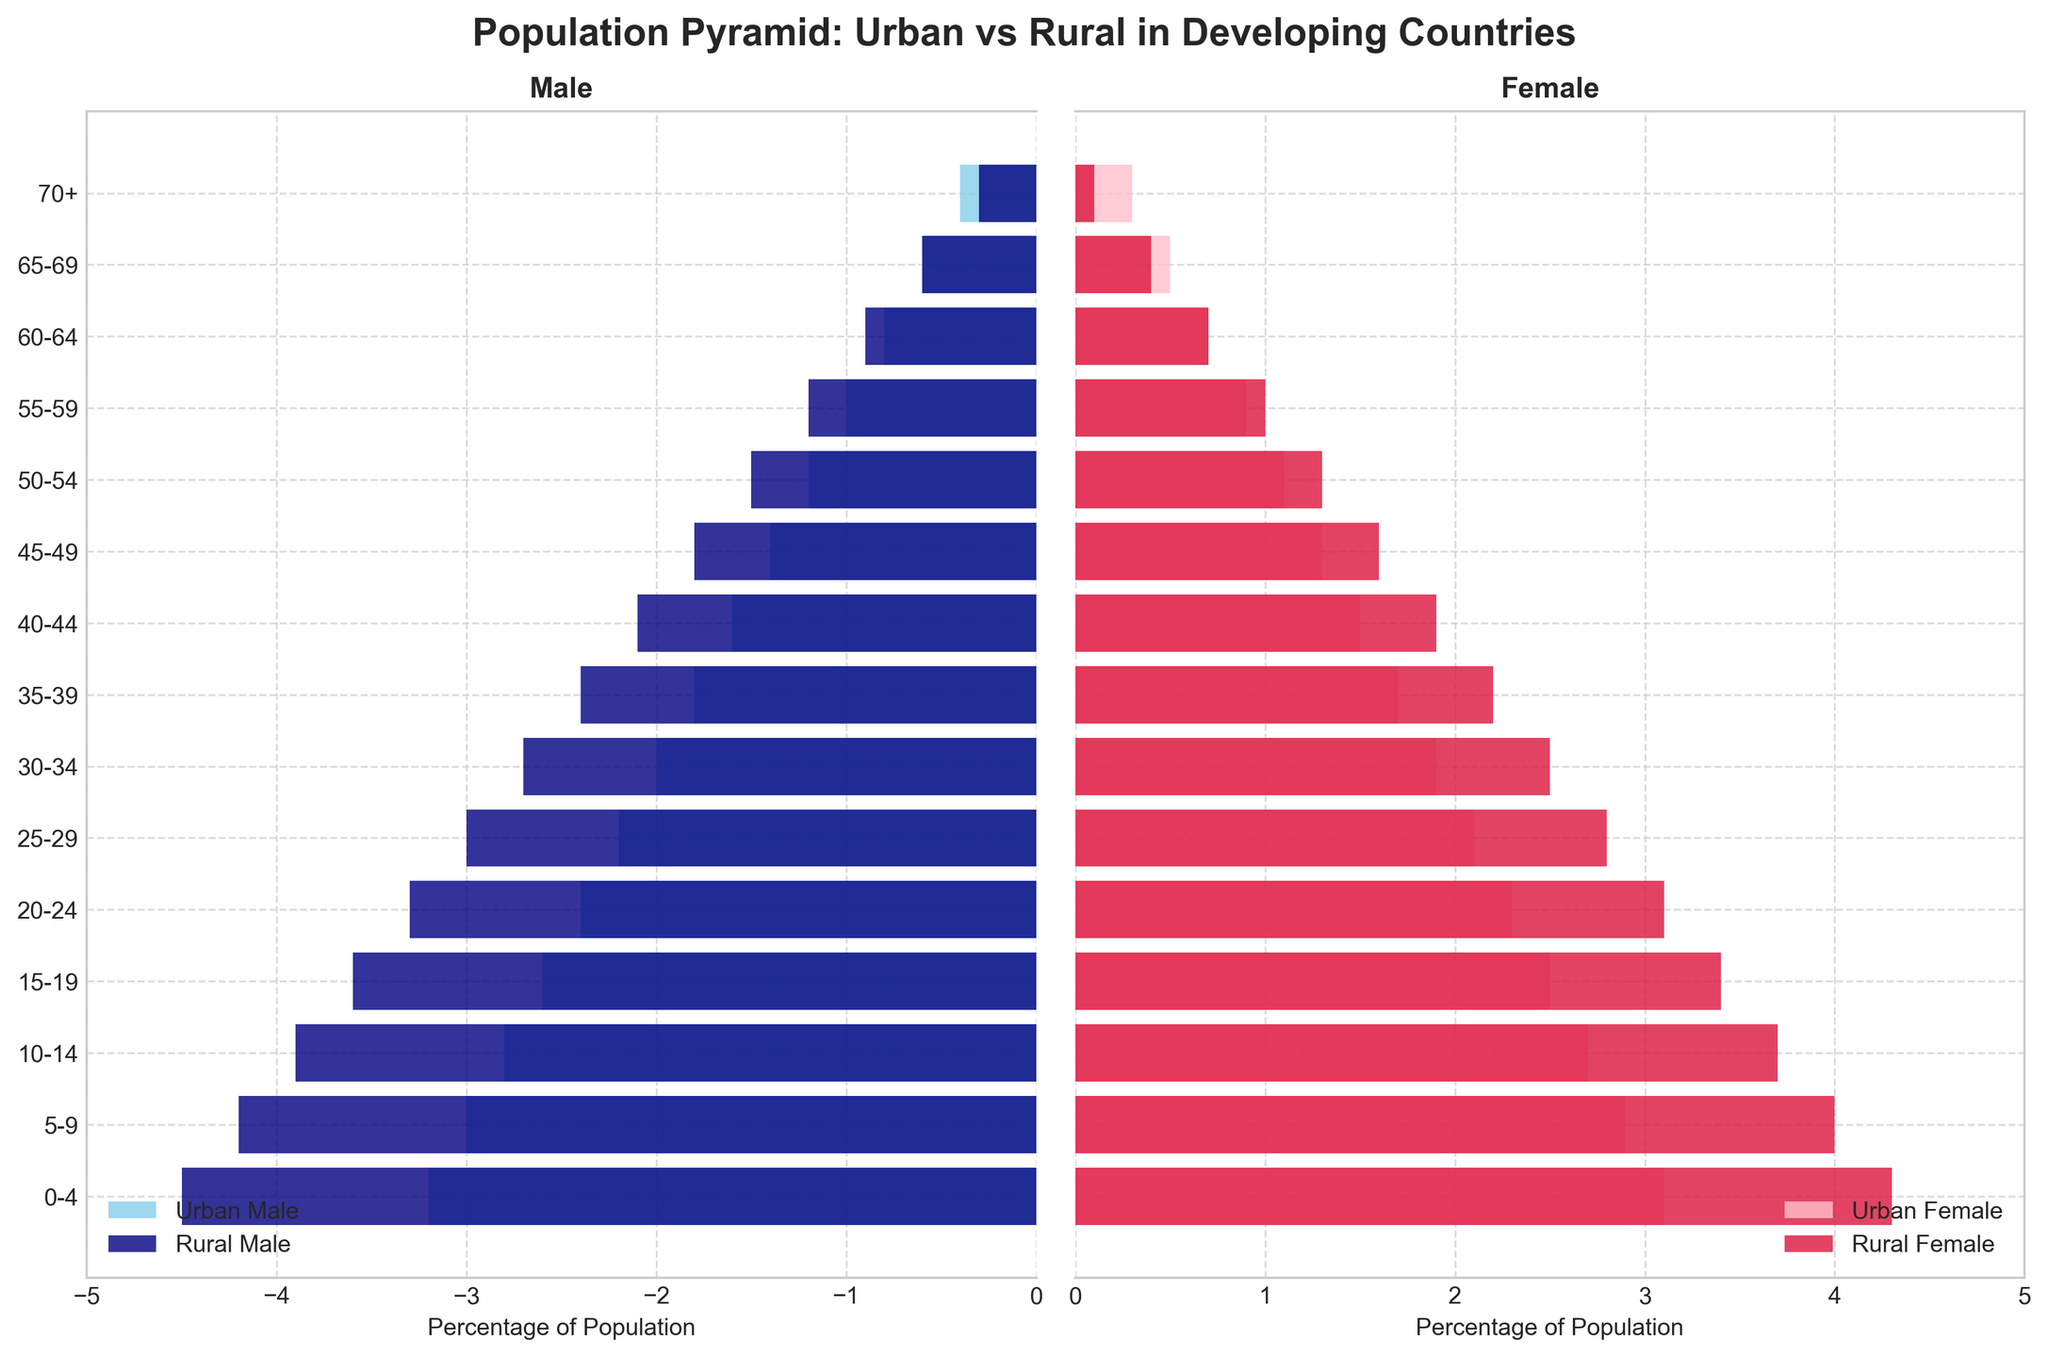What is the title of the figure? The title is displayed at the top center of the figure. It reads "Population Pyramid: Urban vs Rural in Developing Countries".
Answer: Population Pyramid: Urban vs Rural in Developing Countries Which color represents Urban Male in the figure? Colors are used to differentiate categories. The Urban Male category is represented by a sky blue color.
Answer: Sky blue How many age groups are shown in the figure? The age groups are listed on the vertical axis. Counting each group from 0-4 to 70+ gives us a total of 15 age groups.
Answer: 15 For the age group 20-24, which population is larger, rural females or urban females? By looking horizontally at the age group 20-24, the bar for rural females (crimson) is longer than the bar for urban females (pink), indicating a larger population.
Answer: Rural females In which age group is the percentage of urban females equal to 1.1%? The percentage of urban females (pink bar) at 1.1% is indicated on the horizontal axis. The corresponding age group for this percentage is 50-54.
Answer: 50-54 What is the sum of the percentages for urban males and urban females in the 30-34 age group? In the 30-34 age group, urban males make up 2.0% and urban females make up 1.9%. Summing these values gives: 2.0 + 1.9 = 3.9%.
Answer: 3.9% Which gender and population type show the steepest decline in percentage from age group 0-4 to 70+? Observe the trend for each gender and population type. Rural females decline from 4.3% in 0-4 to 0.1% in 70+, which is the steepest decline.
Answer: Rural females How does the percentage of rural males in the 15-19 age group compare to that of urban males in the same group? Comparing their lengths, rural males have a higher percentage (3.6%) compared to urban males (2.6%) in the 15-19 age group.
Answer: Rural males have a higher percentage Which age group has the highest percentage for urban males? Observing the negative (left) side, the longest bar for urban males corresponds to the 0-4 age group at 3.2%.
Answer: 0-4 What is the difference in population percentage between rural males and rural females in the 55-59 age group? The percentage for rural males is 1.2% and for rural females is 1.0%. The difference is calculated as 1.2 - 1.0 = 0.2%.
Answer: 0.2% 